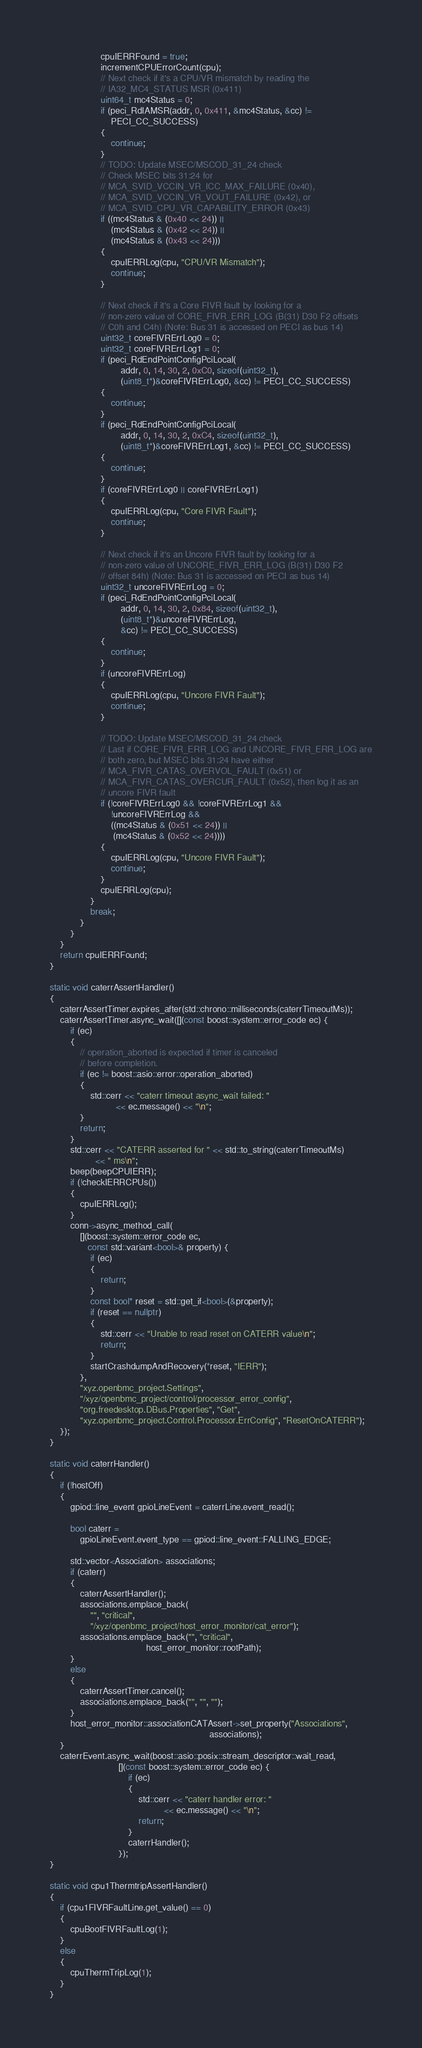Convert code to text. <code><loc_0><loc_0><loc_500><loc_500><_C++_>                    cpuIERRFound = true;
                    incrementCPUErrorCount(cpu);
                    // Next check if it's a CPU/VR mismatch by reading the
                    // IA32_MC4_STATUS MSR (0x411)
                    uint64_t mc4Status = 0;
                    if (peci_RdIAMSR(addr, 0, 0x411, &mc4Status, &cc) !=
                        PECI_CC_SUCCESS)
                    {
                        continue;
                    }
                    // TODO: Update MSEC/MSCOD_31_24 check
                    // Check MSEC bits 31:24 for
                    // MCA_SVID_VCCIN_VR_ICC_MAX_FAILURE (0x40),
                    // MCA_SVID_VCCIN_VR_VOUT_FAILURE (0x42), or
                    // MCA_SVID_CPU_VR_CAPABILITY_ERROR (0x43)
                    if ((mc4Status & (0x40 << 24)) ||
                        (mc4Status & (0x42 << 24)) ||
                        (mc4Status & (0x43 << 24)))
                    {
                        cpuIERRLog(cpu, "CPU/VR Mismatch");
                        continue;
                    }

                    // Next check if it's a Core FIVR fault by looking for a
                    // non-zero value of CORE_FIVR_ERR_LOG (B(31) D30 F2 offsets
                    // C0h and C4h) (Note: Bus 31 is accessed on PECI as bus 14)
                    uint32_t coreFIVRErrLog0 = 0;
                    uint32_t coreFIVRErrLog1 = 0;
                    if (peci_RdEndPointConfigPciLocal(
                            addr, 0, 14, 30, 2, 0xC0, sizeof(uint32_t),
                            (uint8_t*)&coreFIVRErrLog0, &cc) != PECI_CC_SUCCESS)
                    {
                        continue;
                    }
                    if (peci_RdEndPointConfigPciLocal(
                            addr, 0, 14, 30, 2, 0xC4, sizeof(uint32_t),
                            (uint8_t*)&coreFIVRErrLog1, &cc) != PECI_CC_SUCCESS)
                    {
                        continue;
                    }
                    if (coreFIVRErrLog0 || coreFIVRErrLog1)
                    {
                        cpuIERRLog(cpu, "Core FIVR Fault");
                        continue;
                    }

                    // Next check if it's an Uncore FIVR fault by looking for a
                    // non-zero value of UNCORE_FIVR_ERR_LOG (B(31) D30 F2
                    // offset 84h) (Note: Bus 31 is accessed on PECI as bus 14)
                    uint32_t uncoreFIVRErrLog = 0;
                    if (peci_RdEndPointConfigPciLocal(
                            addr, 0, 14, 30, 2, 0x84, sizeof(uint32_t),
                            (uint8_t*)&uncoreFIVRErrLog,
                            &cc) != PECI_CC_SUCCESS)
                    {
                        continue;
                    }
                    if (uncoreFIVRErrLog)
                    {
                        cpuIERRLog(cpu, "Uncore FIVR Fault");
                        continue;
                    }

                    // TODO: Update MSEC/MSCOD_31_24 check
                    // Last if CORE_FIVR_ERR_LOG and UNCORE_FIVR_ERR_LOG are
                    // both zero, but MSEC bits 31:24 have either
                    // MCA_FIVR_CATAS_OVERVOL_FAULT (0x51) or
                    // MCA_FIVR_CATAS_OVERCUR_FAULT (0x52), then log it as an
                    // uncore FIVR fault
                    if (!coreFIVRErrLog0 && !coreFIVRErrLog1 &&
                        !uncoreFIVRErrLog &&
                        ((mc4Status & (0x51 << 24)) ||
                         (mc4Status & (0x52 << 24))))
                    {
                        cpuIERRLog(cpu, "Uncore FIVR Fault");
                        continue;
                    }
                    cpuIERRLog(cpu);
                }
                break;
            }
        }
    }
    return cpuIERRFound;
}

static void caterrAssertHandler()
{
    caterrAssertTimer.expires_after(std::chrono::milliseconds(caterrTimeoutMs));
    caterrAssertTimer.async_wait([](const boost::system::error_code ec) {
        if (ec)
        {
            // operation_aborted is expected if timer is canceled
            // before completion.
            if (ec != boost::asio::error::operation_aborted)
            {
                std::cerr << "caterr timeout async_wait failed: "
                          << ec.message() << "\n";
            }
            return;
        }
        std::cerr << "CATERR asserted for " << std::to_string(caterrTimeoutMs)
                  << " ms\n";
        beep(beepCPUIERR);
        if (!checkIERRCPUs())
        {
            cpuIERRLog();
        }
        conn->async_method_call(
            [](boost::system::error_code ec,
               const std::variant<bool>& property) {
                if (ec)
                {
                    return;
                }
                const bool* reset = std::get_if<bool>(&property);
                if (reset == nullptr)
                {
                    std::cerr << "Unable to read reset on CATERR value\n";
                    return;
                }
                startCrashdumpAndRecovery(*reset, "IERR");
            },
            "xyz.openbmc_project.Settings",
            "/xyz/openbmc_project/control/processor_error_config",
            "org.freedesktop.DBus.Properties", "Get",
            "xyz.openbmc_project.Control.Processor.ErrConfig", "ResetOnCATERR");
    });
}

static void caterrHandler()
{
    if (!hostOff)
    {
        gpiod::line_event gpioLineEvent = caterrLine.event_read();

        bool caterr =
            gpioLineEvent.event_type == gpiod::line_event::FALLING_EDGE;

        std::vector<Association> associations;
        if (caterr)
        {
            caterrAssertHandler();
            associations.emplace_back(
                "", "critical",
                "/xyz/openbmc_project/host_error_monitor/cat_error");
            associations.emplace_back("", "critical",
                                      host_error_monitor::rootPath);
        }
        else
        {
            caterrAssertTimer.cancel();
            associations.emplace_back("", "", "");
        }
        host_error_monitor::associationCATAssert->set_property("Associations",
                                                               associations);
    }
    caterrEvent.async_wait(boost::asio::posix::stream_descriptor::wait_read,
                           [](const boost::system::error_code ec) {
                               if (ec)
                               {
                                   std::cerr << "caterr handler error: "
                                             << ec.message() << "\n";
                                   return;
                               }
                               caterrHandler();
                           });
}

static void cpu1ThermtripAssertHandler()
{
    if (cpu1FIVRFaultLine.get_value() == 0)
    {
        cpuBootFIVRFaultLog(1);
    }
    else
    {
        cpuThermTripLog(1);
    }
}
</code> 